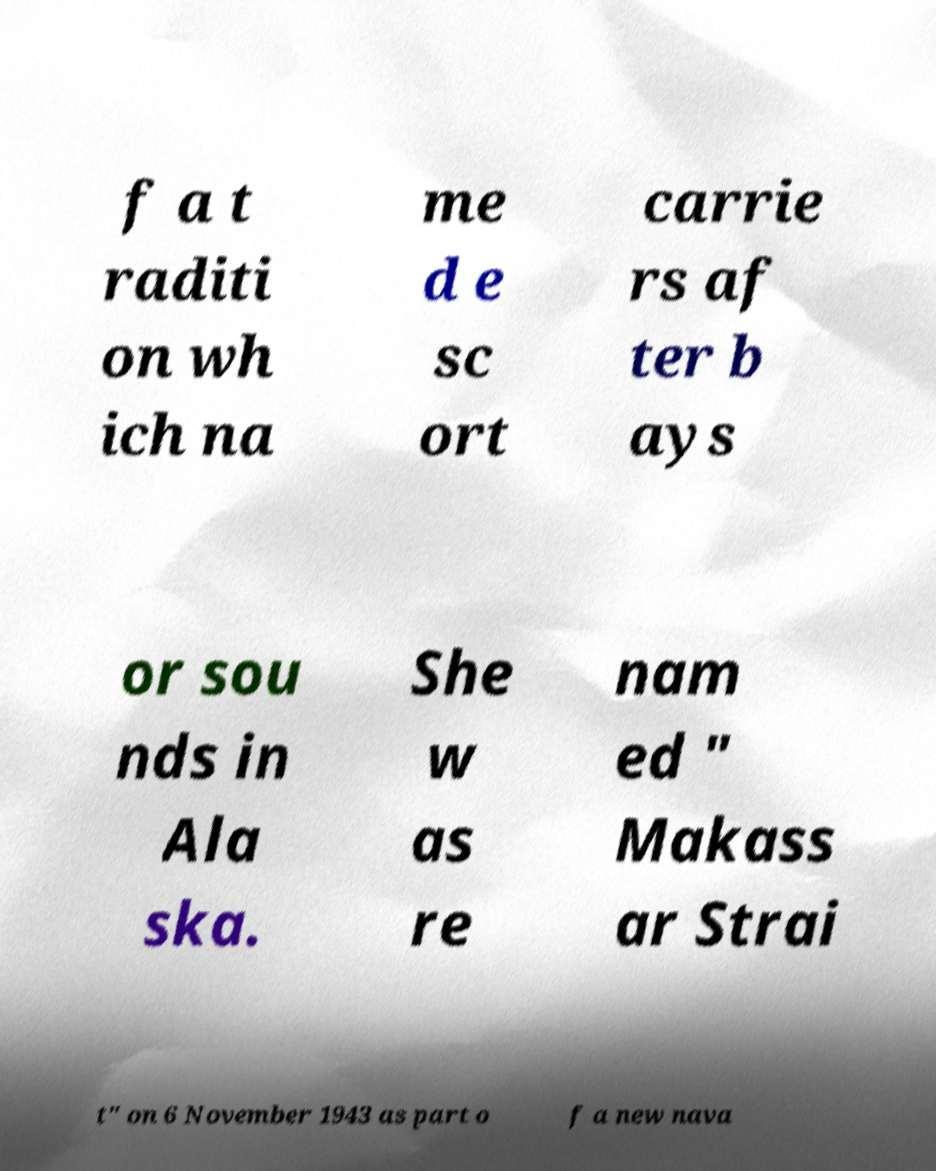Can you read and provide the text displayed in the image?This photo seems to have some interesting text. Can you extract and type it out for me? f a t raditi on wh ich na me d e sc ort carrie rs af ter b ays or sou nds in Ala ska. She w as re nam ed " Makass ar Strai t" on 6 November 1943 as part o f a new nava 